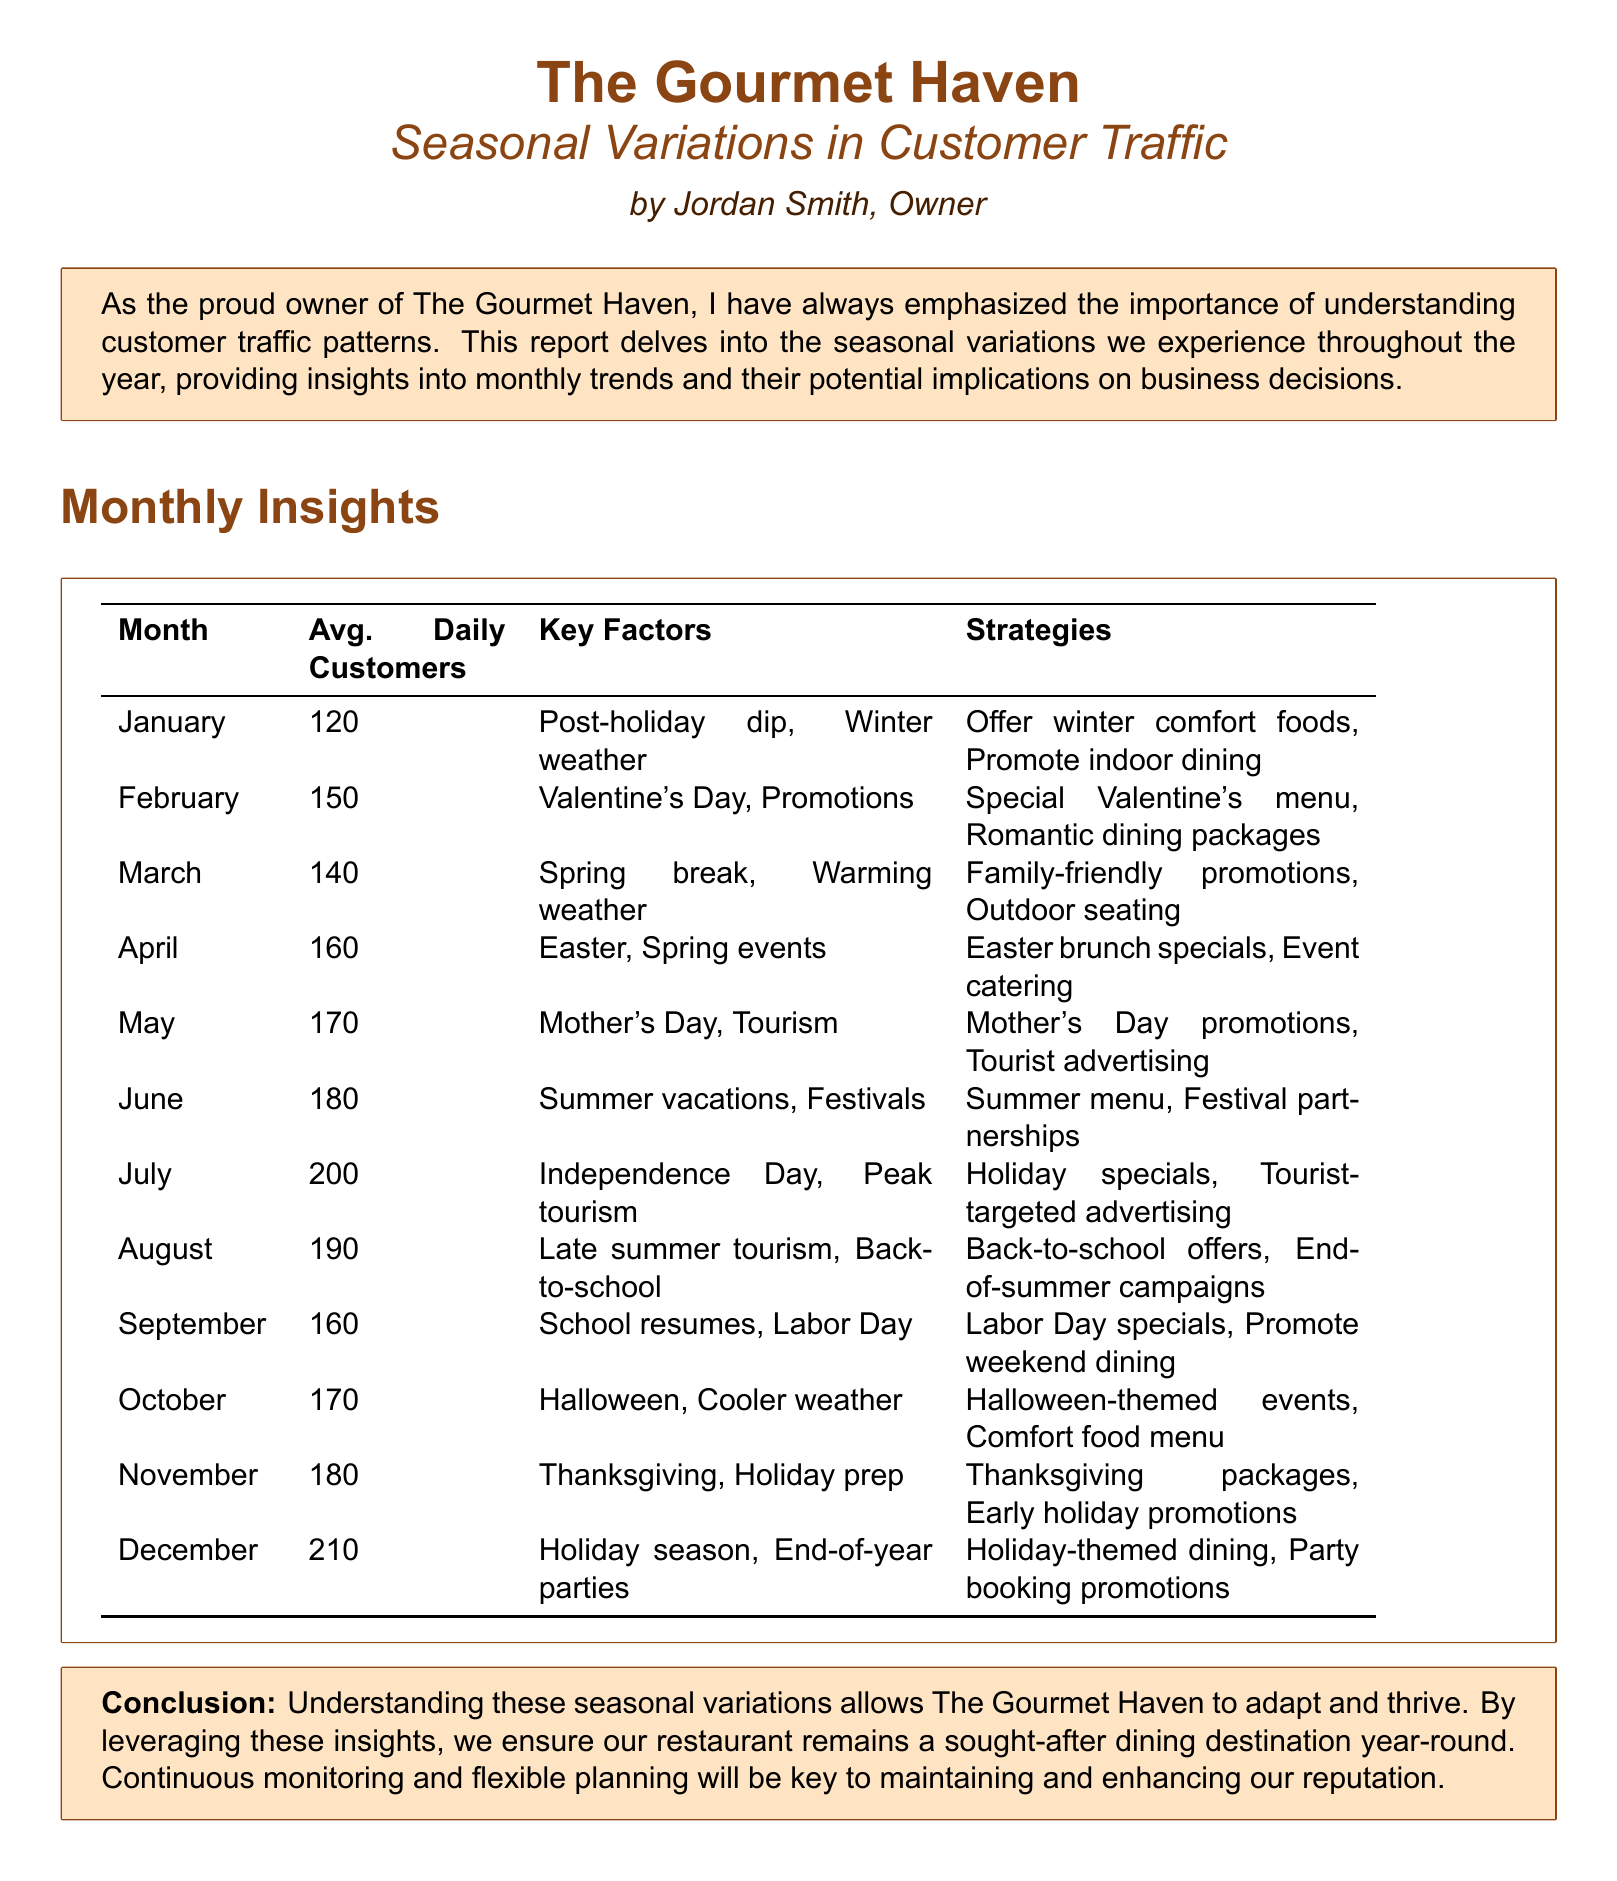What is the average number of daily customers in December? December's average daily customer count is listed in the document.
Answer: 210 Which month has a special promotional event for Valentine's Day? The document specifies key factors related to customer traffic month by month.
Answer: February What is one strategy used in March to attract customers? The strategies listed for March indicate how to attract customers during that month.
Answer: Family-friendly promotions Which month typically sees the highest average daily customers? The data shows daily customer averages per month, identifying the peak month.
Answer: December What key factor affects customer traffic in January? The document outlines the reasons behind customer traffic variations for each month.
Answer: Winter weather How many average daily customers does the restaurant have in September? The average daily customers for September is provided in the monthly insights table.
Answer: 160 What type of event impacts customer traffic in April? The key factors affecting traffic for April are detailed in the report.
Answer: Easter What strategy is suggested for August? The document outlines specific strategies for each month, highlighting strategies for August.
Answer: Back-to-school offers 